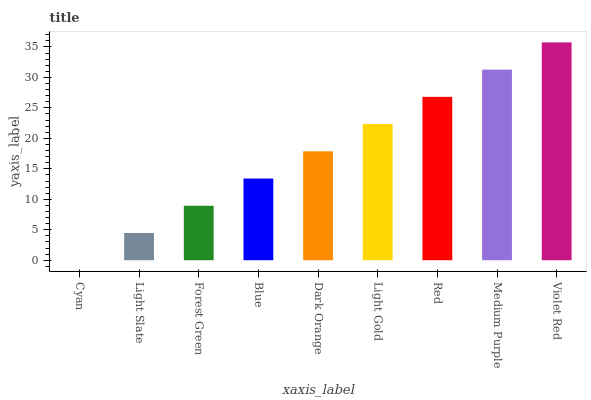Is Cyan the minimum?
Answer yes or no. Yes. Is Violet Red the maximum?
Answer yes or no. Yes. Is Light Slate the minimum?
Answer yes or no. No. Is Light Slate the maximum?
Answer yes or no. No. Is Light Slate greater than Cyan?
Answer yes or no. Yes. Is Cyan less than Light Slate?
Answer yes or no. Yes. Is Cyan greater than Light Slate?
Answer yes or no. No. Is Light Slate less than Cyan?
Answer yes or no. No. Is Dark Orange the high median?
Answer yes or no. Yes. Is Dark Orange the low median?
Answer yes or no. Yes. Is Cyan the high median?
Answer yes or no. No. Is Blue the low median?
Answer yes or no. No. 